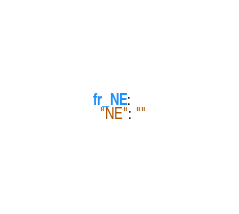<code> <loc_0><loc_0><loc_500><loc_500><_YAML_>fr_NE:
  "NE": ""
</code> 